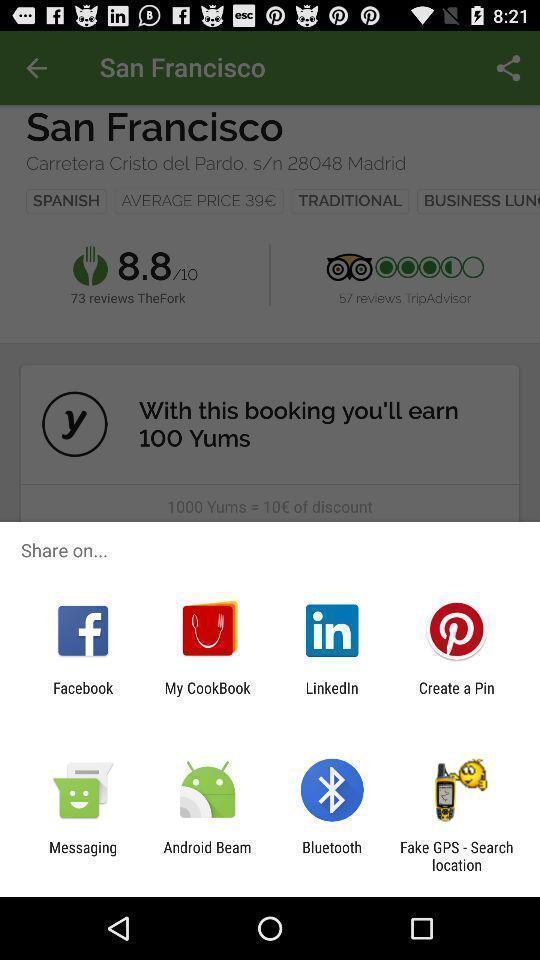Tell me about the visual elements in this screen capture. Share options page of a food booking app. 